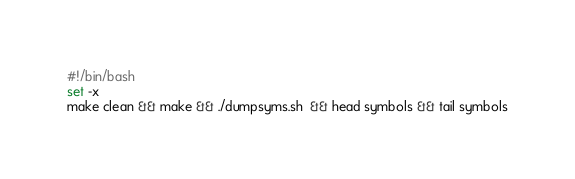<code> <loc_0><loc_0><loc_500><loc_500><_Bash_>#!/bin/bash
set -x
make clean && make && ./dumpsyms.sh  && head symbols && tail symbols
</code> 